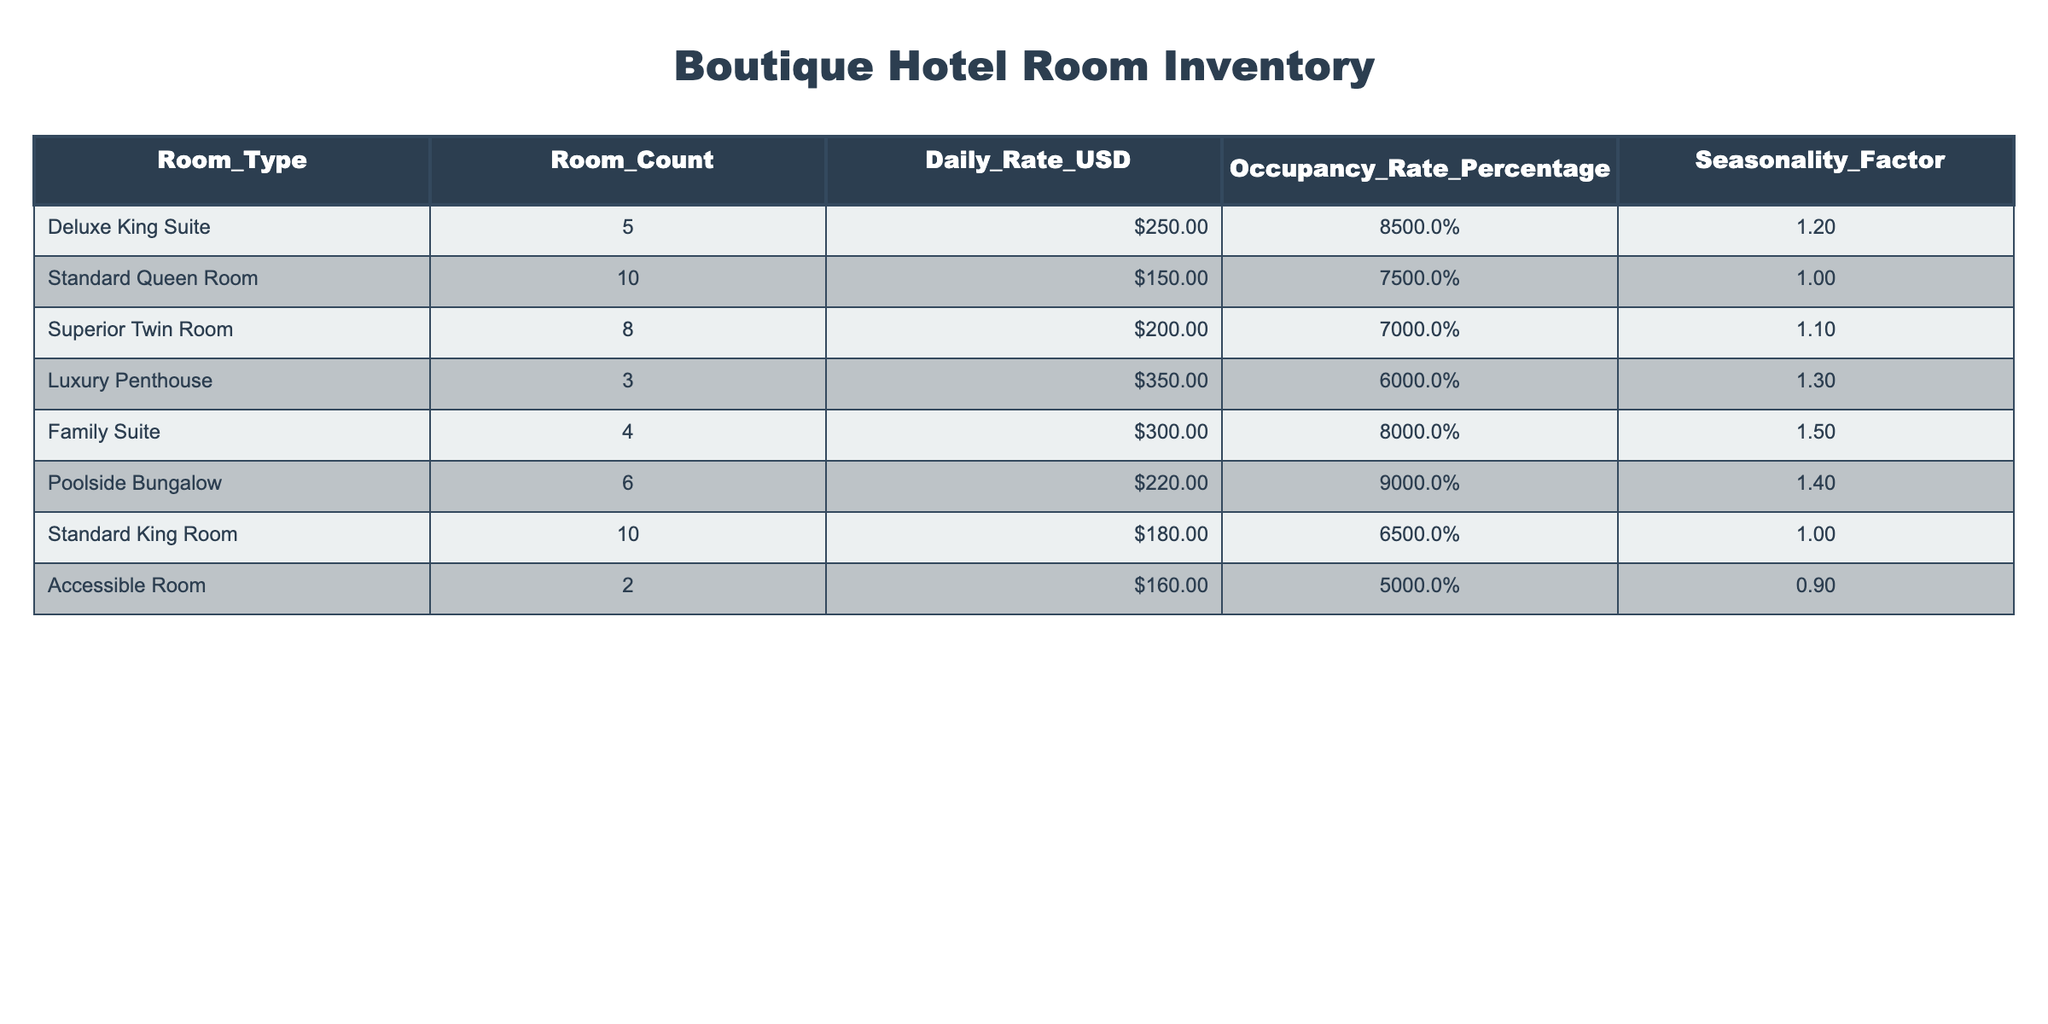What is the Daily Rate for the Luxury Penthouse? Looking at the 'Daily_Rate_USD' column in the Luxury Penthouse row, the value is 350.
Answer: 350 Which room type has the highest Occupancy Rate? By examining the 'Occupancy_Rate_Percentage' column, the Poolside Bungalow has the highest rate at 90%.
Answer: Poolside Bungalow What is the total Room Count across all room types? We sum the values in the 'Room_Count' column: 5 + 10 + 8 + 3 + 4 + 6 + 10 + 2 = 48.
Answer: 48 Is the Occupancy Rate for the Accessible Room above 50%? The Occupancy Rate for the Accessible Room is 50%, which means it is not above 50%.
Answer: No What is the average Daily Rate for all room types? To calculate the average, we sum all the Daily Rates: 250 + 150 + 200 + 350 + 300 + 220 + 180 + 160 = 1810. Then divide by the number of room types (8): 1810 / 8 = 226.25.
Answer: 226.25 Are there more than 4 rooms in the Family Suite category? The 'Room_Count' for Family Suite is 4, therefore it is not more than 4.
Answer: No What is the Seasonality Factor for the Standard Queen Room? The Seasonality Factor can be found in the corresponding row under that column, which is 1.0 for the Standard Queen Room.
Answer: 1.0 Calculate the difference in occupancy rates between the Deluxe King Suite and the Standard King Room. The occupancy rate for the Deluxe King Suite is 85% and for the Standard King Room is 65%. The difference is 85 - 65 = 20%.
Answer: 20% What room type has the highest Daily Rate? The highest Daily Rate is 350 for the Luxury Penthouse listed in the 'Daily_Rate_USD' column.
Answer: Luxury Penthouse 